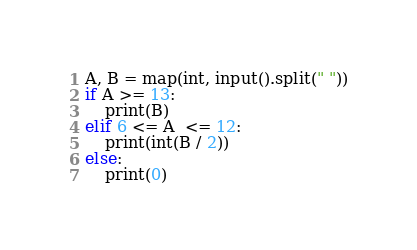<code> <loc_0><loc_0><loc_500><loc_500><_Python_>A, B = map(int, input().split(" "))
if A >= 13:
    print(B)
elif 6 <= A  <= 12:
    print(int(B / 2))
else:
    print(0)</code> 